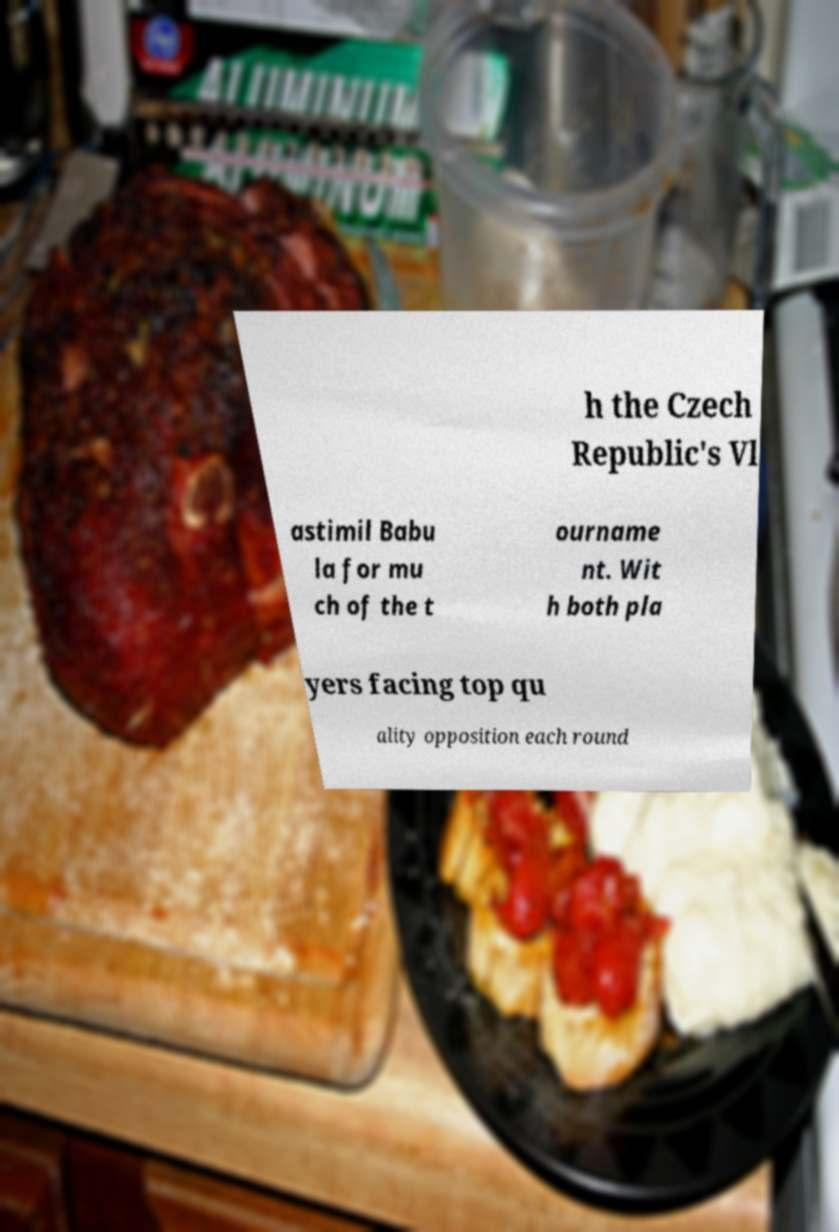Could you assist in decoding the text presented in this image and type it out clearly? h the Czech Republic's Vl astimil Babu la for mu ch of the t ourname nt. Wit h both pla yers facing top qu ality opposition each round 